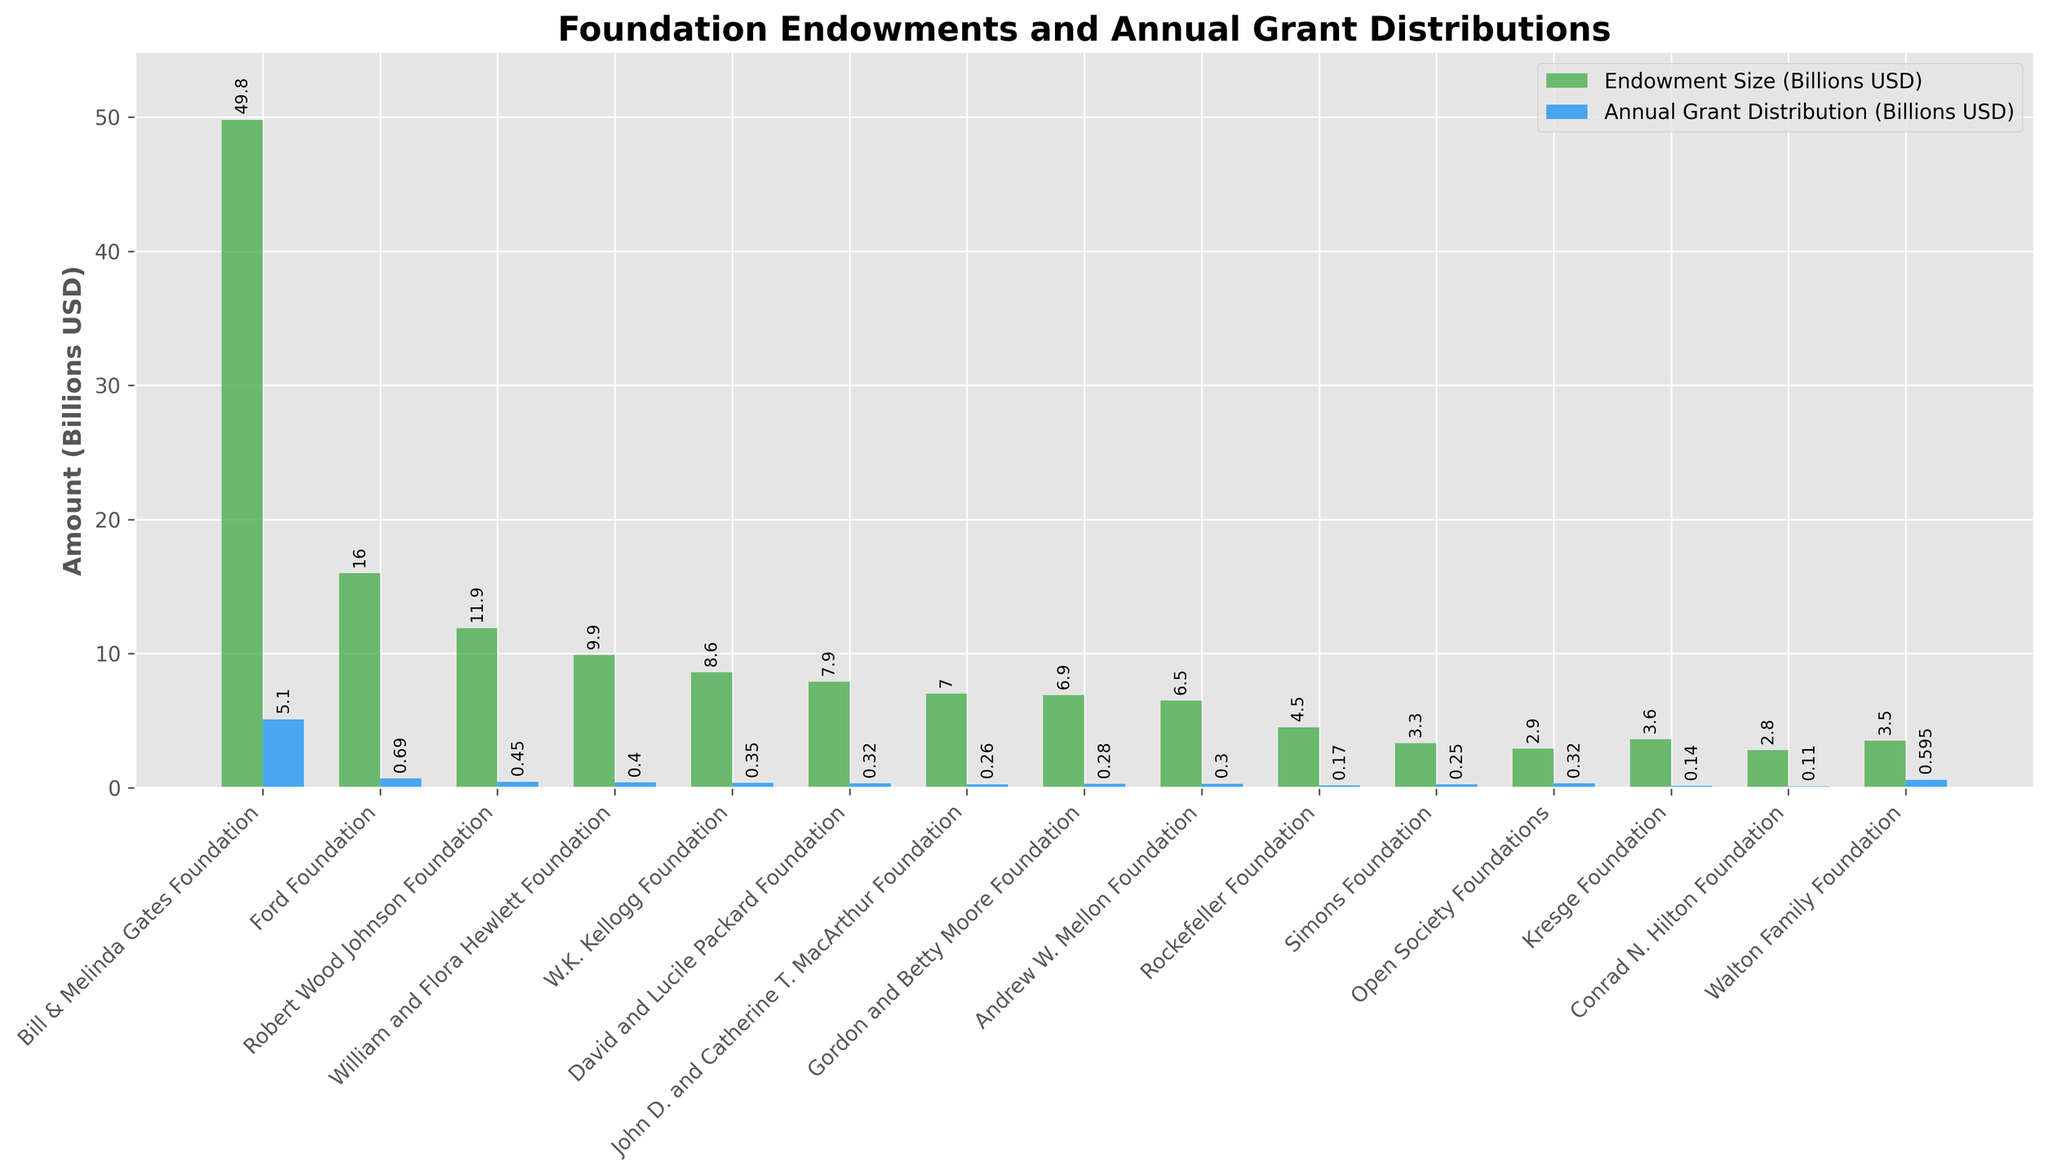What is the difference in annual grant distribution between the Bill & Melinda Gates Foundation and the Ford Foundation? The annual grant distribution for the Bill & Melinda Gates Foundation is 5.1 billion USD, and for the Ford Foundation, it is 690 million USD (or 0.69 billion USD). The difference is 5.1 - 0.69 = 4.41 billion USD.
Answer: 4.41 billion USD Which foundation has the smallest endowment size and what is its annual grant distribution? The foundation with the smallest endowment size is the Conrad N. Hilton Foundation with an endowment size of 2.8 billion USD. Its annual grant distribution is 110 million USD (or 0.11 billion USD).
Answer: Conrad N. Hilton Foundation, 0.11 billion USD What is the ratio of annual grant distribution to endowment size for the Walton Family Foundation? The Walton Family Foundation has an endowment size of 3.5 billion USD and an annual grant distribution of 595 million USD (or 0.595 billion USD). The ratio is 0.595 / 3.5 ≈ 0.17.
Answer: 0.17 Compare the endowment sizes of the Ford Foundation and the William and Flora Hewlett Foundation. Which one is larger and by how much? The endowment size of the Ford Foundation is 16.0 billion USD, and the William and Flora Hewlett Foundation is 9.9 billion USD. The Ford Foundation's endowment size is larger by 16.0 - 9.9 = 6.1 billion USD.
Answer: Ford Foundation, 6.1 billion USD Among the foundations listed, which has the highest annual grant distribution, and what is its endowment size? The foundation with the highest annual grant distribution is the Bill & Melinda Gates Foundation at 5.1 billion USD. Its endowment size is 49.8 billion USD.
Answer: Bill & Melinda Gates Foundation, 49.8 billion USD What is the total endowment size for the top three foundations by annual grant distribution? The top three foundations by annual grant distribution are Bill & Melinda Gates Foundation (5.1 billion USD), Walton Family Foundation (0.595 billion USD), and Ford Foundation (0.69 billion USD). Their endowment sizes are 49.8 + 3.5 + 16.0 = 69.3 billion USD.
Answer: 69.3 billion USD Compare the annual grant distributions of the Gordon and Betty Moore Foundation and the Open Society Foundations. Which foundation distributes more annually, and by how much? The annual grant distribution for the Gordon and Betty Moore Foundation is 280 million USD (or 0.28 billion USD), and for the Open Society Foundations, it is 320 million USD (or 0.32 billion USD). The Open Society Foundations distribute more annually by 0.32 - 0.28 = 0.04 billion USD.
Answer: Open Society Foundations, 0.04 billion USD What is the average endowment size of the foundations listed? The total endowment size of all foundations listed is (49.8 + 16.0 + 11.9 + 9.9 + 8.6 + 7.9 + 7.0 + 6.9 + 6.5 + 4.5 + 3.3 + 2.9 + 3.6 + 2.8 + 3.5) = 144.1 billion USD. With 15 foundations, the average endowment size is 144.1 / 15 ≈ 9.61 billion USD.
Answer: 9.61 billion USD 